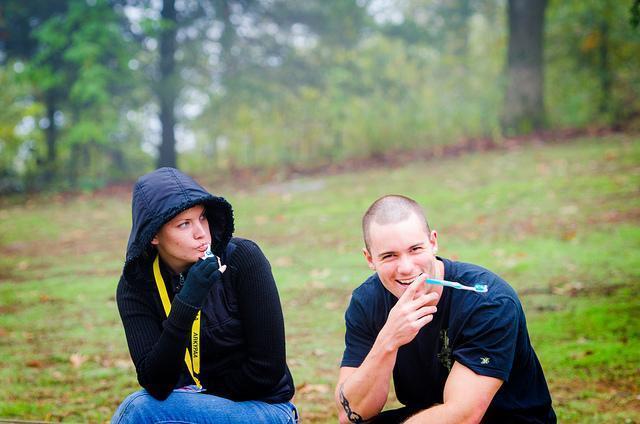How many people are there?
Give a very brief answer. 2. 